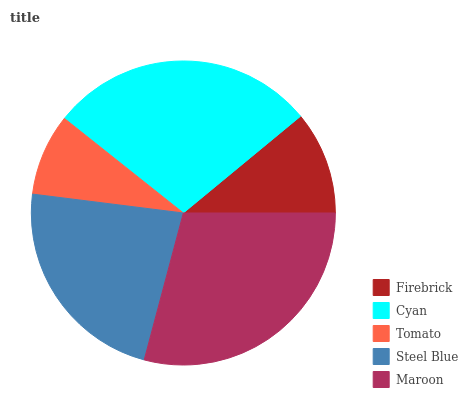Is Tomato the minimum?
Answer yes or no. Yes. Is Maroon the maximum?
Answer yes or no. Yes. Is Cyan the minimum?
Answer yes or no. No. Is Cyan the maximum?
Answer yes or no. No. Is Cyan greater than Firebrick?
Answer yes or no. Yes. Is Firebrick less than Cyan?
Answer yes or no. Yes. Is Firebrick greater than Cyan?
Answer yes or no. No. Is Cyan less than Firebrick?
Answer yes or no. No. Is Steel Blue the high median?
Answer yes or no. Yes. Is Steel Blue the low median?
Answer yes or no. Yes. Is Cyan the high median?
Answer yes or no. No. Is Firebrick the low median?
Answer yes or no. No. 